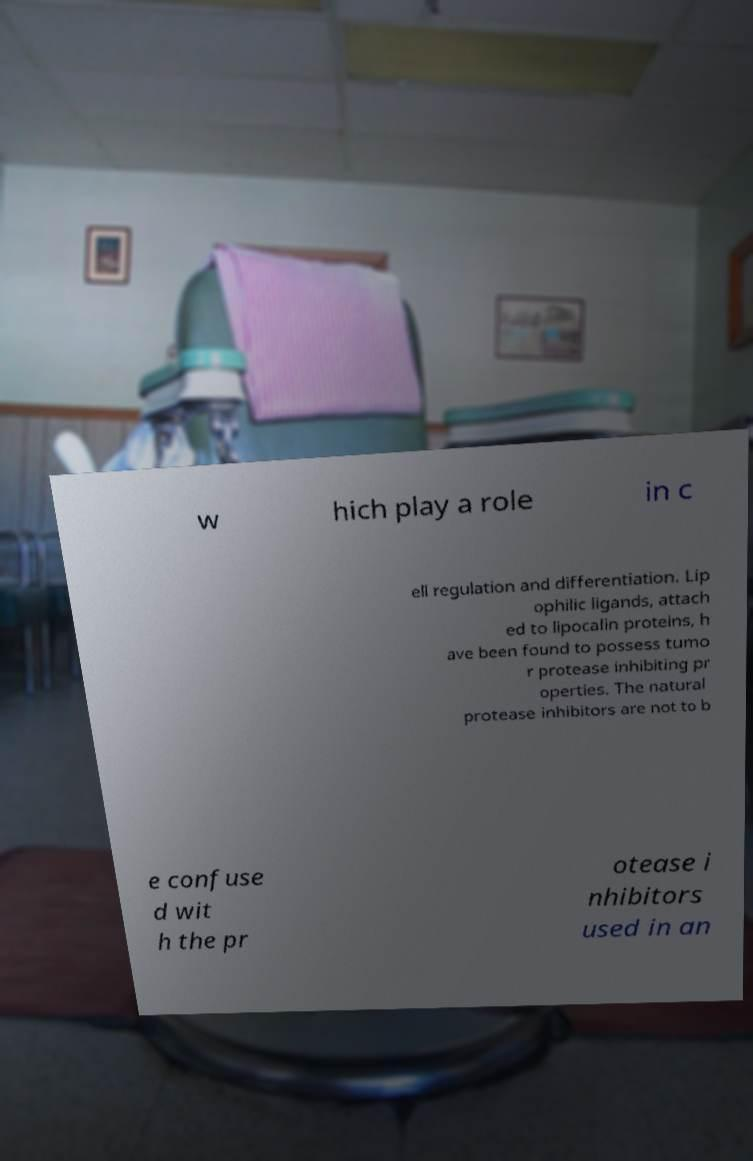Please identify and transcribe the text found in this image. w hich play a role in c ell regulation and differentiation. Lip ophilic ligands, attach ed to lipocalin proteins, h ave been found to possess tumo r protease inhibiting pr operties. The natural protease inhibitors are not to b e confuse d wit h the pr otease i nhibitors used in an 